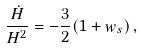Convert formula to latex. <formula><loc_0><loc_0><loc_500><loc_500>\frac { \dot { H } } { H ^ { 2 } } = - \frac { 3 } { 2 } ( 1 + w _ { s } ) \, ,</formula> 